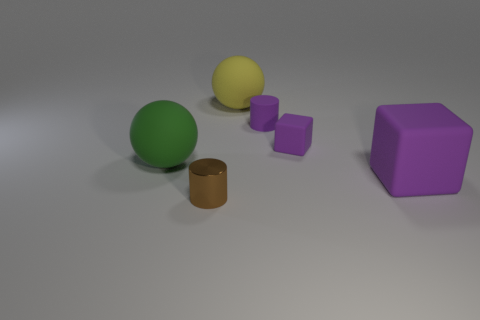The green ball that is made of the same material as the yellow ball is what size?
Offer a very short reply. Large. Is the yellow thing made of the same material as the brown cylinder?
Your answer should be compact. No. How many other objects are there of the same material as the small purple cylinder?
Keep it short and to the point. 4. What number of large objects are both to the left of the tiny purple rubber block and in front of the big green rubber object?
Your answer should be very brief. 0. What is the color of the big rubber block?
Offer a very short reply. Purple. There is a small purple object that is the same shape as the brown metal thing; what is it made of?
Provide a short and direct response. Rubber. Is there any other thing that is made of the same material as the small brown thing?
Make the answer very short. No. Is the big cube the same color as the small matte block?
Your answer should be compact. Yes. There is a small thing in front of the sphere that is in front of the yellow sphere; what shape is it?
Keep it short and to the point. Cylinder. What shape is the large purple thing that is made of the same material as the big yellow ball?
Your response must be concise. Cube. 